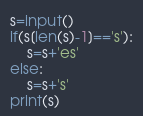<code> <loc_0><loc_0><loc_500><loc_500><_Python_>s=input()
if(s[len(s)-1]=='s'):
    s=s+'es'
else:
    s=s+'s'
print(s)</code> 